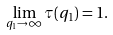Convert formula to latex. <formula><loc_0><loc_0><loc_500><loc_500>\lim _ { q _ { 1 } \rightarrow \infty } \tau ( q _ { 1 } ) = 1 .</formula> 